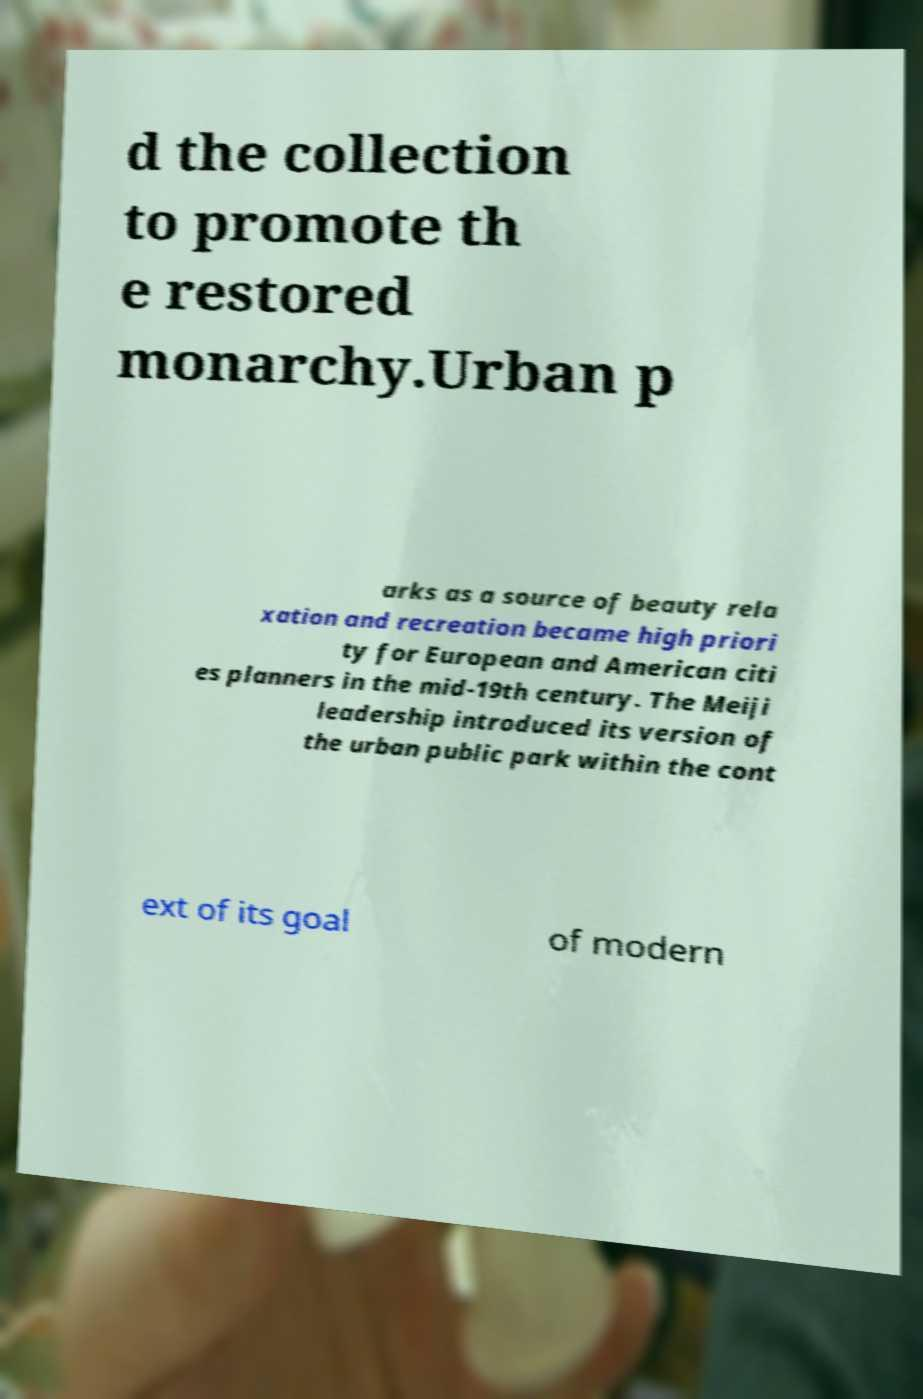I need the written content from this picture converted into text. Can you do that? d the collection to promote th e restored monarchy.Urban p arks as a source of beauty rela xation and recreation became high priori ty for European and American citi es planners in the mid-19th century. The Meiji leadership introduced its version of the urban public park within the cont ext of its goal of modern 